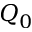<formula> <loc_0><loc_0><loc_500><loc_500>Q _ { 0 }</formula> 